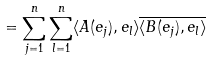<formula> <loc_0><loc_0><loc_500><loc_500>= \sum _ { j = 1 } ^ { n } \sum _ { l = 1 } ^ { n } \langle A ( e _ { j } ) , e _ { l } \rangle \overline { \langle B ( e _ { j } ) , e _ { l } \rangle }</formula> 